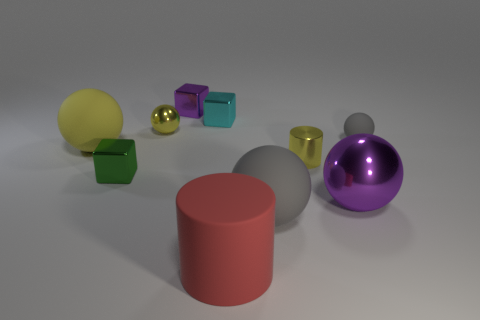Are there fewer big yellow things than big gray rubber cylinders?
Your response must be concise. No. How big is the sphere that is in front of the yellow matte thing and to the right of the small yellow shiny cylinder?
Your answer should be very brief. Large. There is a yellow metal object in front of the yellow shiny thing to the left of the gray object that is in front of the green thing; what size is it?
Provide a short and direct response. Small. What number of other objects are there of the same color as the big cylinder?
Your response must be concise. 0. There is a small metallic cylinder on the right side of the green metallic object; is its color the same as the big metal sphere?
Your response must be concise. No. How many things are either cyan things or tiny purple shiny objects?
Make the answer very short. 2. What is the color of the metallic cube in front of the big yellow rubber sphere?
Ensure brevity in your answer.  Green. Is the number of gray rubber balls in front of the cyan cube less than the number of big blocks?
Give a very brief answer. No. The rubber ball that is the same color as the small metal ball is what size?
Keep it short and to the point. Large. Are there any other things that are the same size as the metallic cylinder?
Offer a very short reply. Yes. 